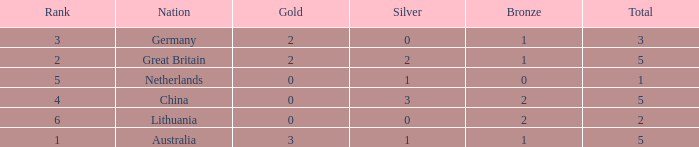What is the number for rank when gold is less than 0? None. 